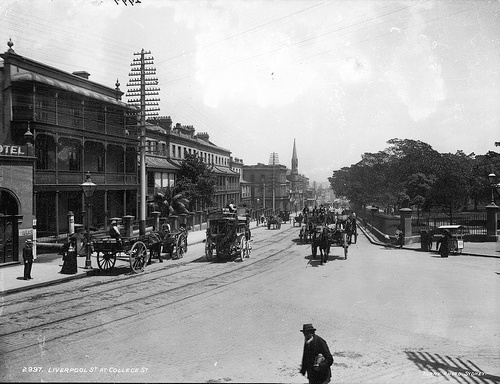Describe the objects in this image and their specific colors. I can see people in lightgray, black, gray, and darkgray tones, people in lightgray, black, gray, and darkgray tones, people in lightgray, black, and gray tones, horse in black, gray, darkgray, and lightgray tones, and people in black, gray, darkgray, and lightgray tones in this image. 